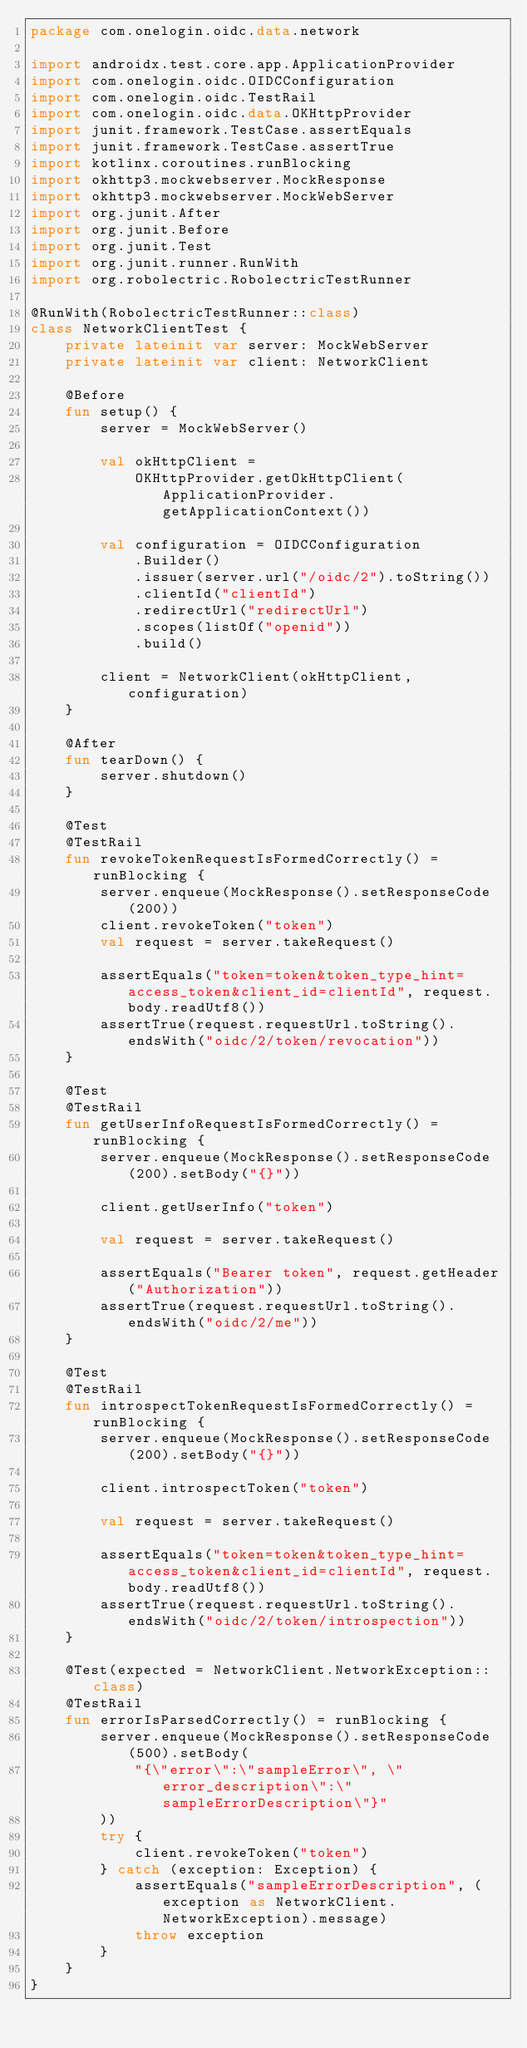<code> <loc_0><loc_0><loc_500><loc_500><_Kotlin_>package com.onelogin.oidc.data.network

import androidx.test.core.app.ApplicationProvider
import com.onelogin.oidc.OIDCConfiguration
import com.onelogin.oidc.TestRail
import com.onelogin.oidc.data.OKHttpProvider
import junit.framework.TestCase.assertEquals
import junit.framework.TestCase.assertTrue
import kotlinx.coroutines.runBlocking
import okhttp3.mockwebserver.MockResponse
import okhttp3.mockwebserver.MockWebServer
import org.junit.After
import org.junit.Before
import org.junit.Test
import org.junit.runner.RunWith
import org.robolectric.RobolectricTestRunner

@RunWith(RobolectricTestRunner::class)
class NetworkClientTest {
    private lateinit var server: MockWebServer
    private lateinit var client: NetworkClient

    @Before
    fun setup() {
        server = MockWebServer()

        val okHttpClient =
            OKHttpProvider.getOkHttpClient(ApplicationProvider.getApplicationContext())

        val configuration = OIDCConfiguration
            .Builder()
            .issuer(server.url("/oidc/2").toString())
            .clientId("clientId")
            .redirectUrl("redirectUrl")
            .scopes(listOf("openid"))
            .build()

        client = NetworkClient(okHttpClient, configuration)
    }

    @After
    fun tearDown() {
        server.shutdown()
    }

    @Test
    @TestRail
    fun revokeTokenRequestIsFormedCorrectly() = runBlocking {
        server.enqueue(MockResponse().setResponseCode(200))
        client.revokeToken("token")
        val request = server.takeRequest()

        assertEquals("token=token&token_type_hint=access_token&client_id=clientId", request.body.readUtf8())
        assertTrue(request.requestUrl.toString().endsWith("oidc/2/token/revocation"))
    }

    @Test
    @TestRail
    fun getUserInfoRequestIsFormedCorrectly() = runBlocking {
        server.enqueue(MockResponse().setResponseCode(200).setBody("{}"))

        client.getUserInfo("token")

        val request = server.takeRequest()

        assertEquals("Bearer token", request.getHeader("Authorization"))
        assertTrue(request.requestUrl.toString().endsWith("oidc/2/me"))
    }

    @Test
    @TestRail
    fun introspectTokenRequestIsFormedCorrectly() = runBlocking {
        server.enqueue(MockResponse().setResponseCode(200).setBody("{}"))

        client.introspectToken("token")

        val request = server.takeRequest()

        assertEquals("token=token&token_type_hint=access_token&client_id=clientId", request.body.readUtf8())
        assertTrue(request.requestUrl.toString().endsWith("oidc/2/token/introspection"))
    }

    @Test(expected = NetworkClient.NetworkException::class)
    @TestRail
    fun errorIsParsedCorrectly() = runBlocking {
        server.enqueue(MockResponse().setResponseCode(500).setBody(
            "{\"error\":\"sampleError\", \"error_description\":\"sampleErrorDescription\"}"
        ))
        try {
            client.revokeToken("token")
        } catch (exception: Exception) {
            assertEquals("sampleErrorDescription", (exception as NetworkClient.NetworkException).message)
            throw exception
        }
    }
}
</code> 